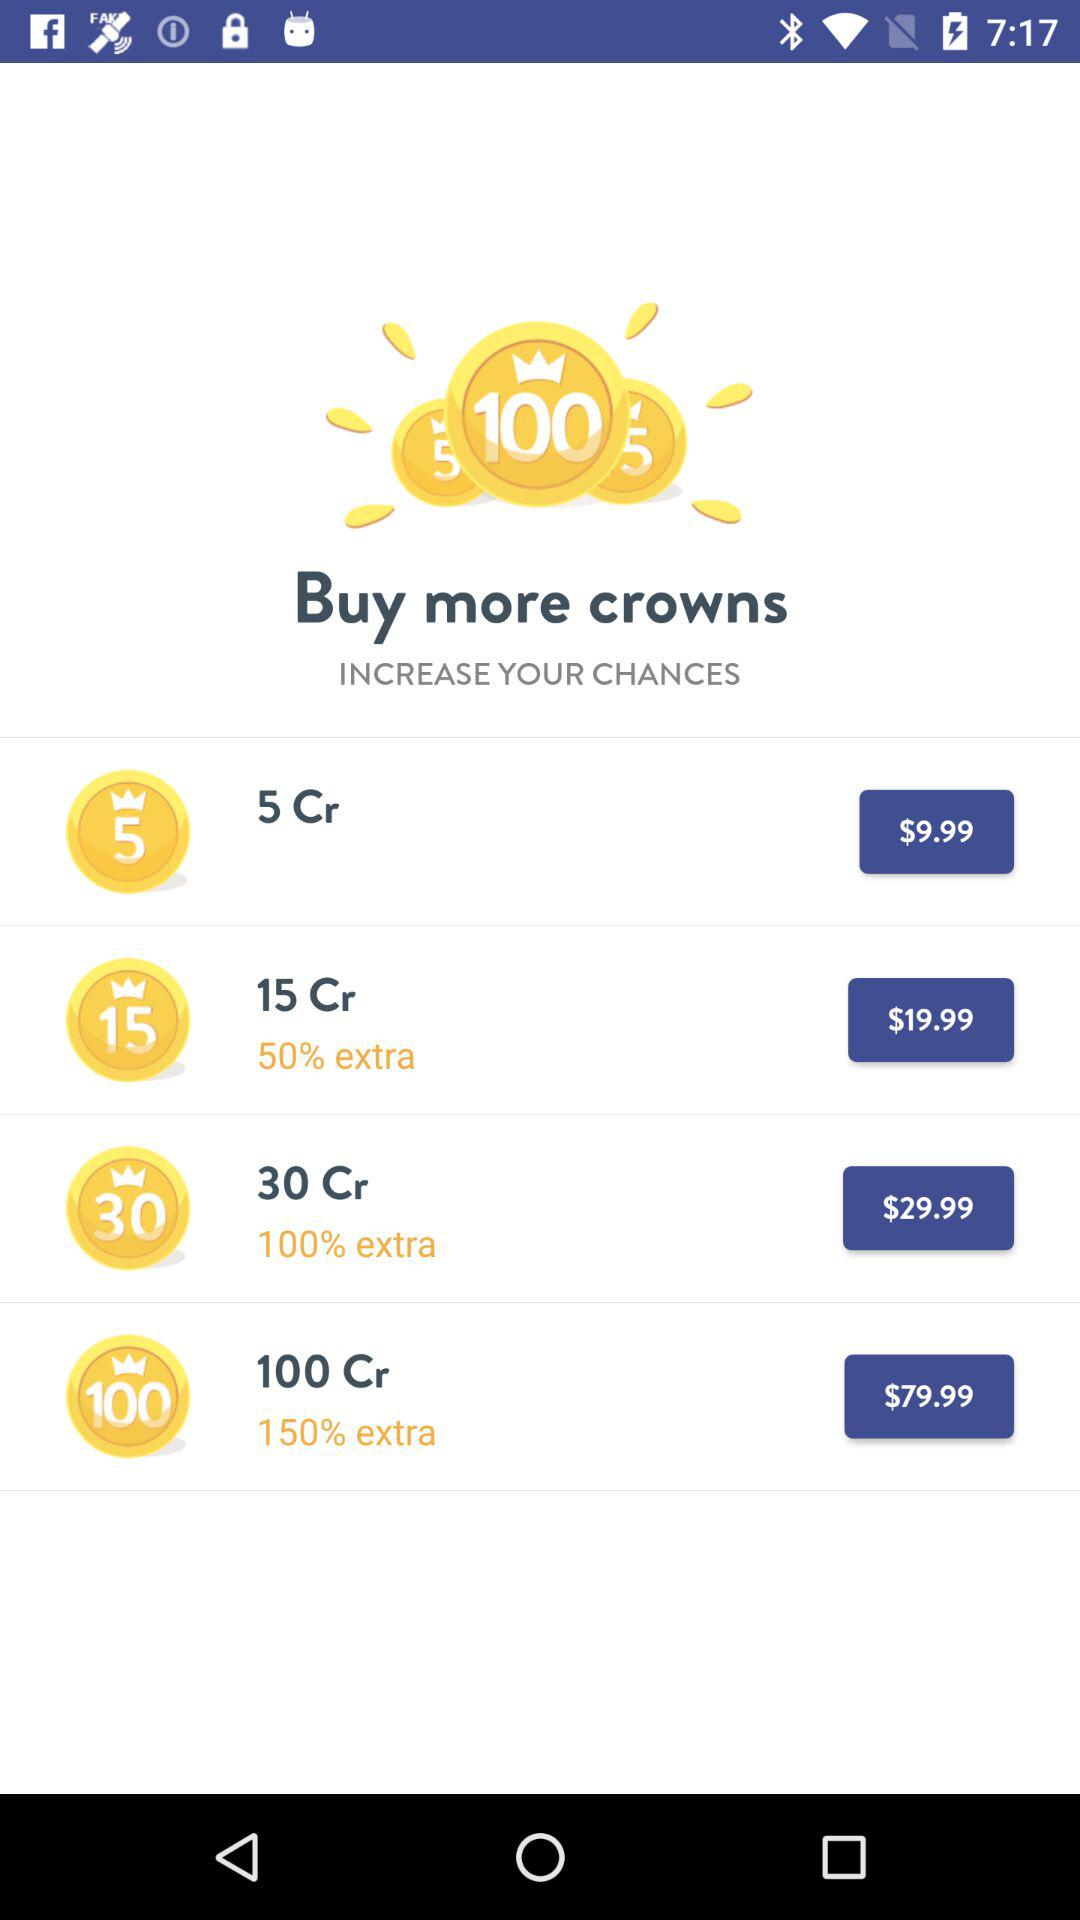How many crowns are in the most expensive package?
Answer the question using a single word or phrase. 100 